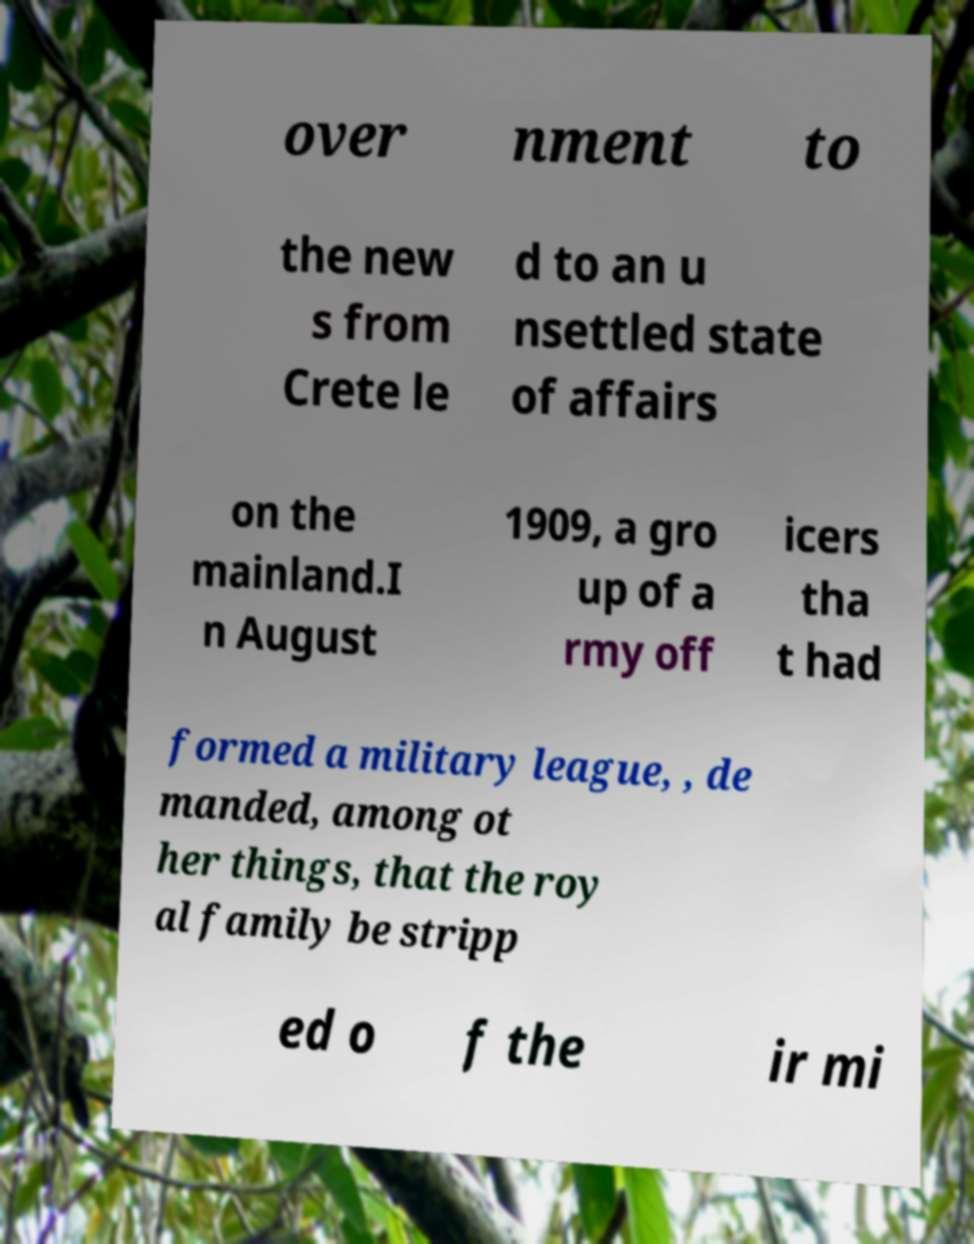There's text embedded in this image that I need extracted. Can you transcribe it verbatim? over nment to the new s from Crete le d to an u nsettled state of affairs on the mainland.I n August 1909, a gro up of a rmy off icers tha t had formed a military league, , de manded, among ot her things, that the roy al family be stripp ed o f the ir mi 